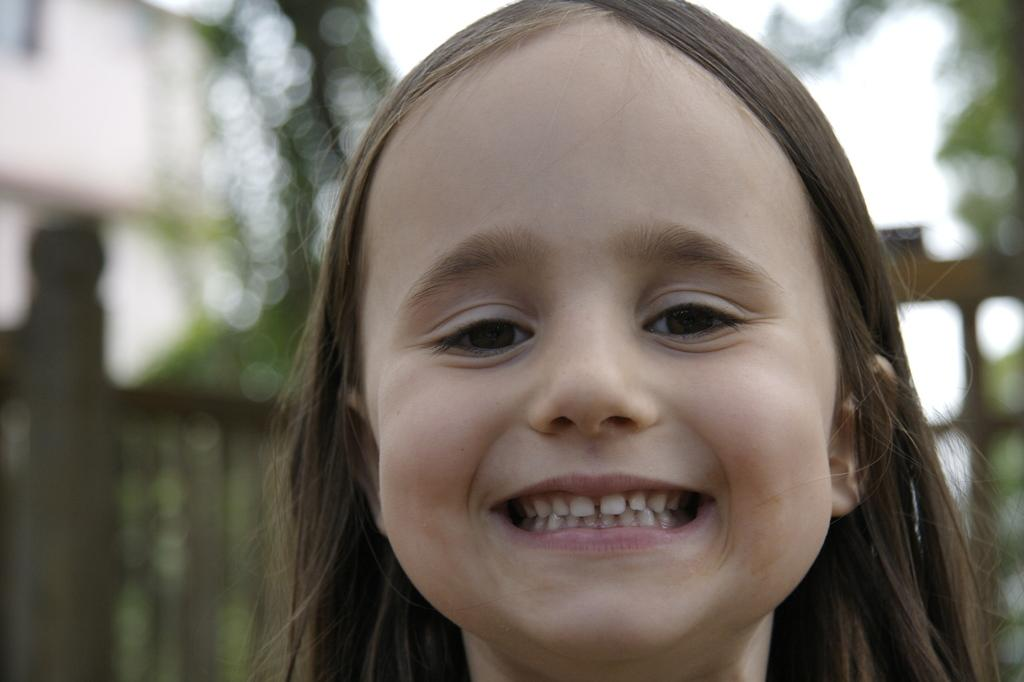Where was the image taken? The image is taken outdoors. What can be seen in the background of the image? There is a tree and a fence in the background of the image. Who is the main subject in the image? There is a girl in the middle of the image. What is the girl's facial expression? The girl has a smiling face. What is the title of the book the girl is holding in the image? There is no book present in the image, so there is no title to mention. 